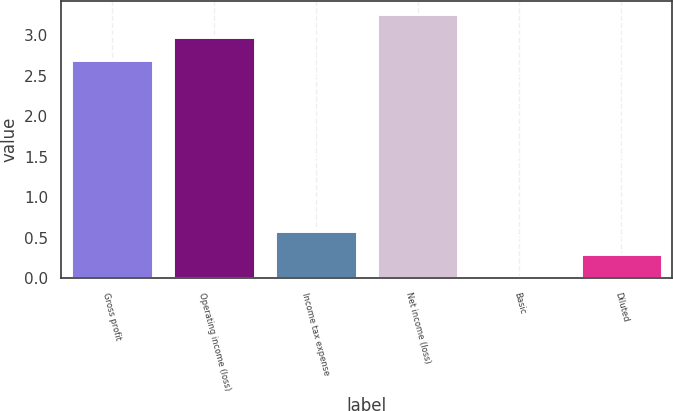Convert chart. <chart><loc_0><loc_0><loc_500><loc_500><bar_chart><fcel>Gross profit<fcel>Operating income (loss)<fcel>Income tax expense<fcel>Net income (loss)<fcel>Basic<fcel>Diluted<nl><fcel>2.7<fcel>2.98<fcel>0.58<fcel>3.26<fcel>0.02<fcel>0.3<nl></chart> 